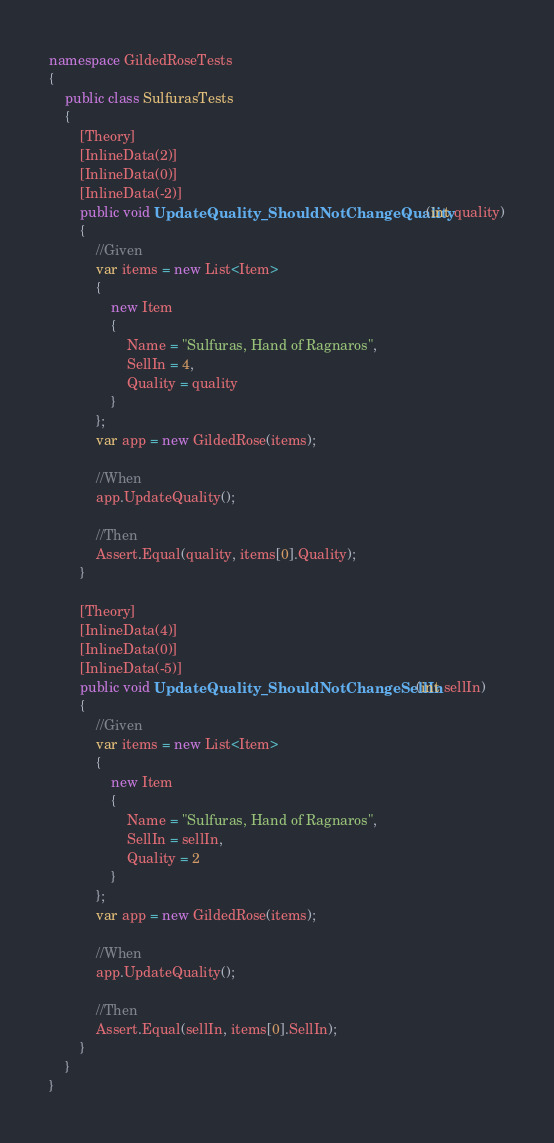Convert code to text. <code><loc_0><loc_0><loc_500><loc_500><_C#_>namespace GildedRoseTests
{
    public class SulfurasTests
    {
        [Theory]
        [InlineData(2)]
        [InlineData(0)]
        [InlineData(-2)]
        public void UpdateQuality_ShouldNotChangeQuality(int quality)
        {
            //Given
            var items = new List<Item>
            {
                new Item
                {
                    Name = "Sulfuras, Hand of Ragnaros",
                    SellIn = 4,
                    Quality = quality
                }
            };
            var app = new GildedRose(items);
            
            //When
            app.UpdateQuality();

            //Then
            Assert.Equal(quality, items[0].Quality);
        }

        [Theory]
        [InlineData(4)]
        [InlineData(0)]
        [InlineData(-5)]
        public void UpdateQuality_ShouldNotChangeSellIn(int sellIn)
        {
            //Given
            var items = new List<Item>
            {
                new Item
                {
                    Name = "Sulfuras, Hand of Ragnaros",
                    SellIn = sellIn,
                    Quality = 2
                }
            };
            var app = new GildedRose(items);

            //When
            app.UpdateQuality();

            //Then
            Assert.Equal(sellIn, items[0].SellIn);
        }
    }
}
</code> 